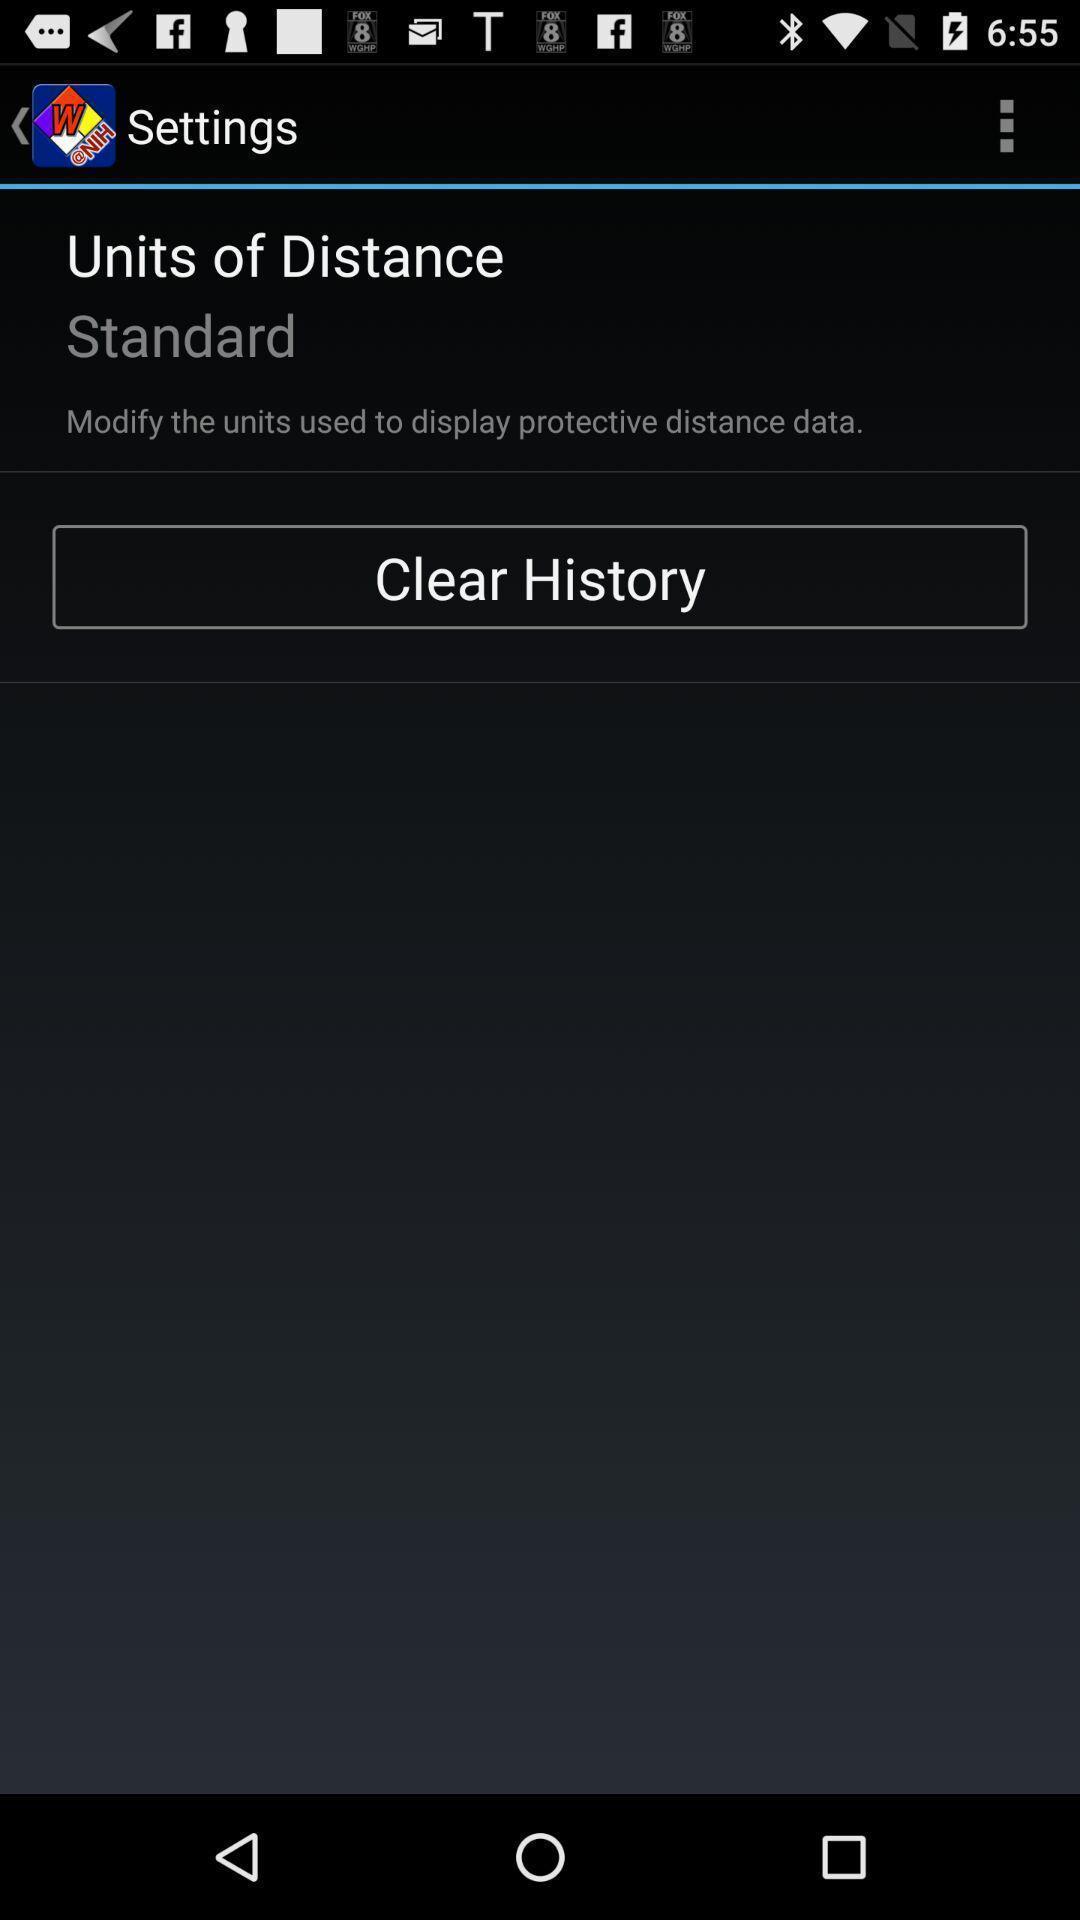Tell me about the visual elements in this screen capture. Settings page. 